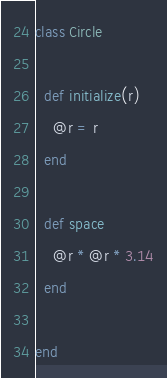Convert code to text. <code><loc_0><loc_0><loc_500><loc_500><_Ruby_>class Circle

  def initialize(r)
    @r = r
  end

  def space
    @r * @r * 3.14
  end

end
</code> 